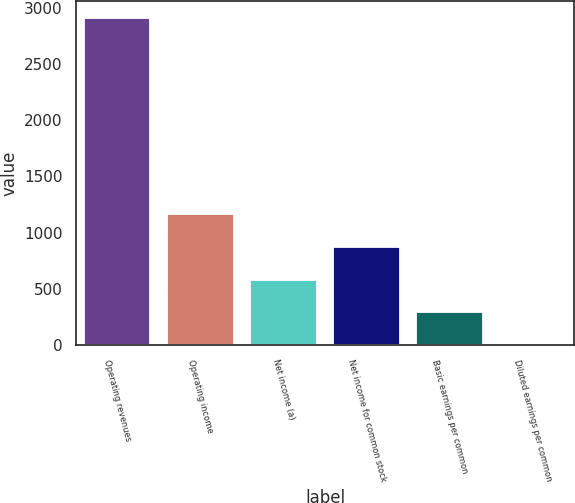Convert chart to OTSL. <chart><loc_0><loc_0><loc_500><loc_500><bar_chart><fcel>Operating revenues<fcel>Operating income<fcel>Net income (a)<fcel>Net income for common stock<fcel>Basic earnings per common<fcel>Diluted earnings per common<nl><fcel>2911<fcel>1164.84<fcel>582.78<fcel>873.81<fcel>291.75<fcel>0.72<nl></chart> 